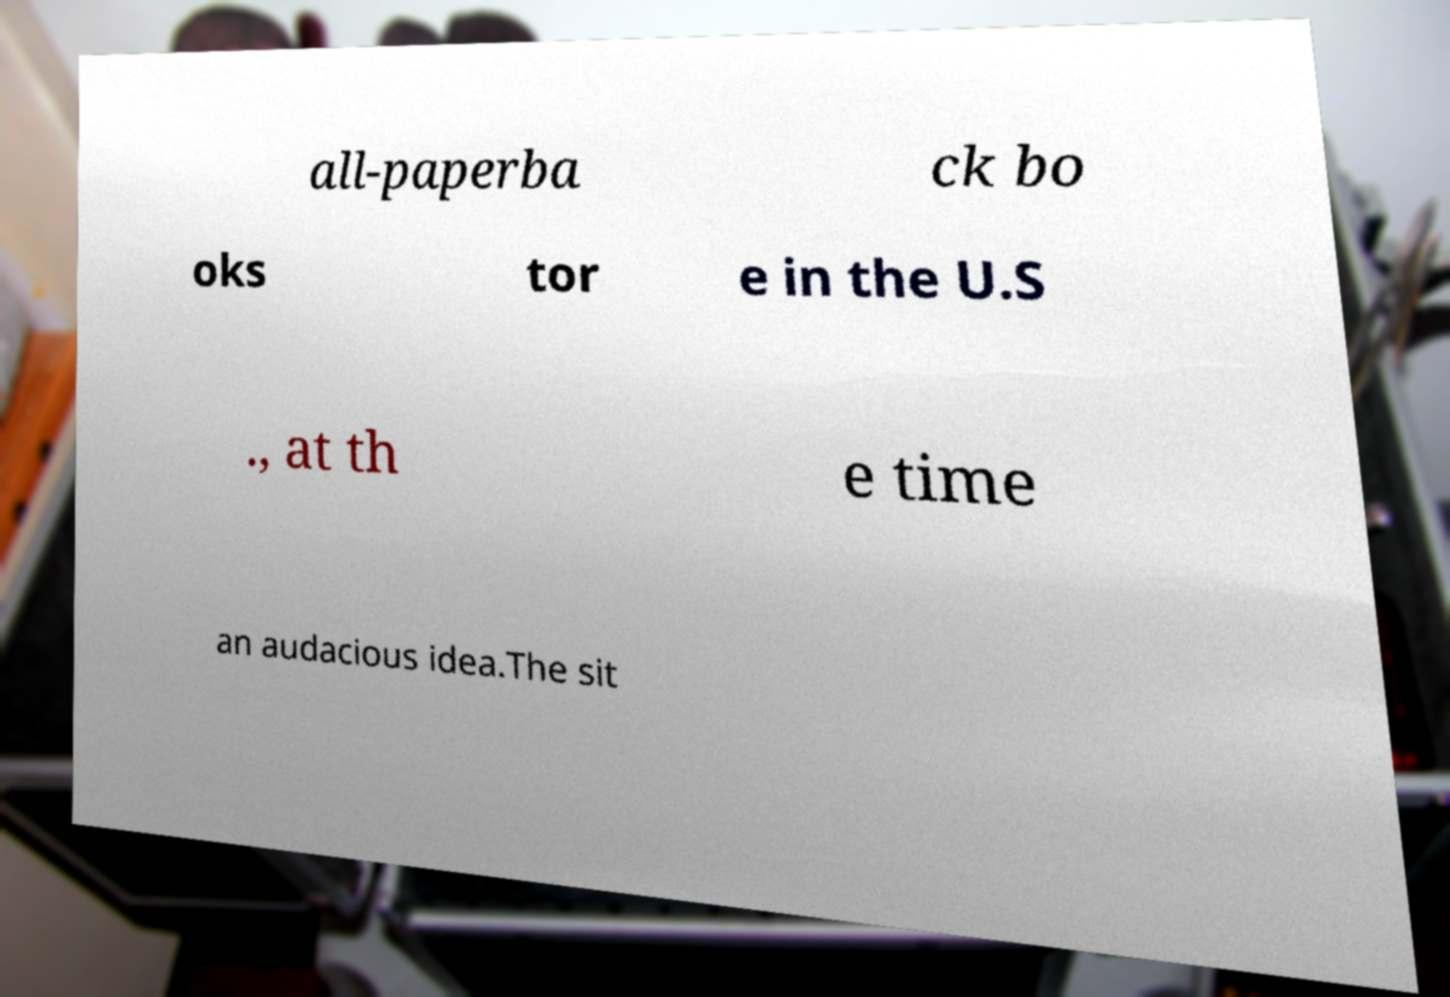Please read and relay the text visible in this image. What does it say? all-paperba ck bo oks tor e in the U.S ., at th e time an audacious idea.The sit 